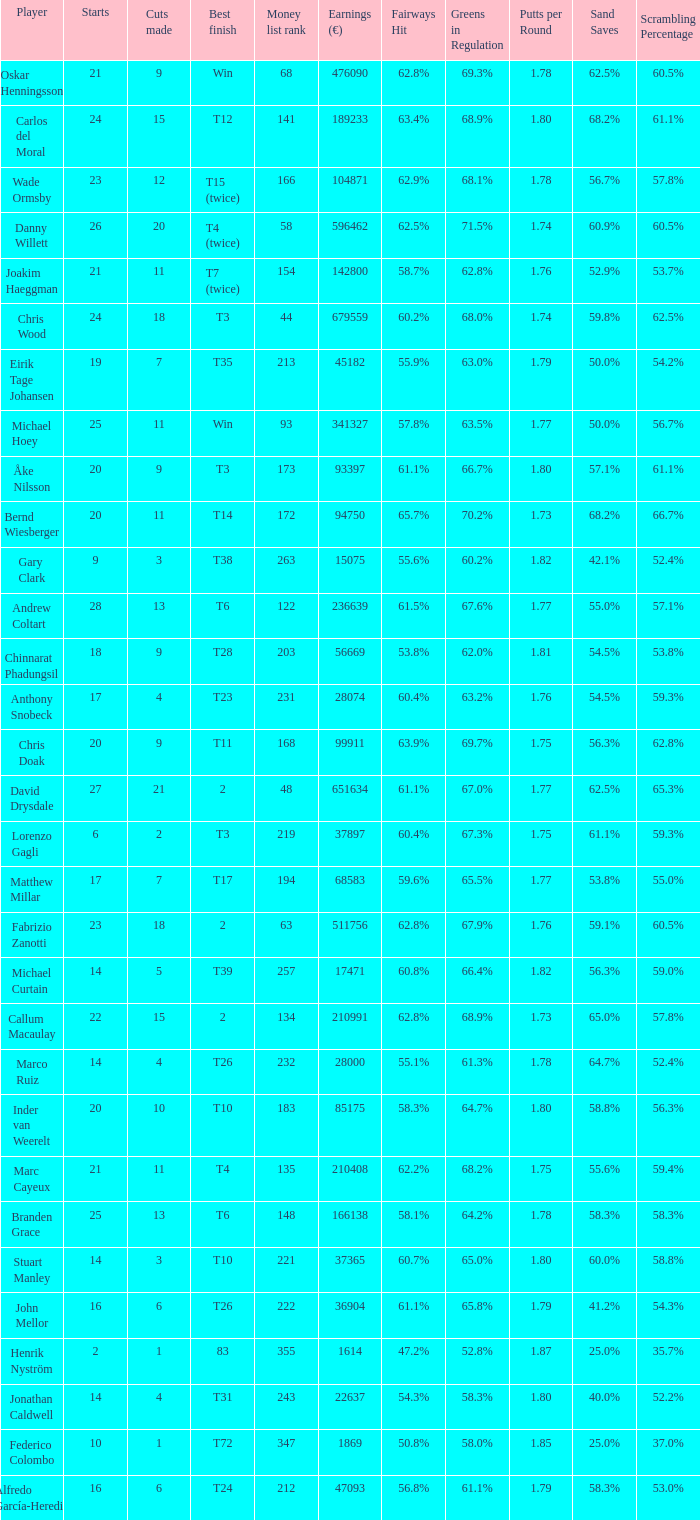How many slices did the athlete who gained 210408 euro make? 11.0. 